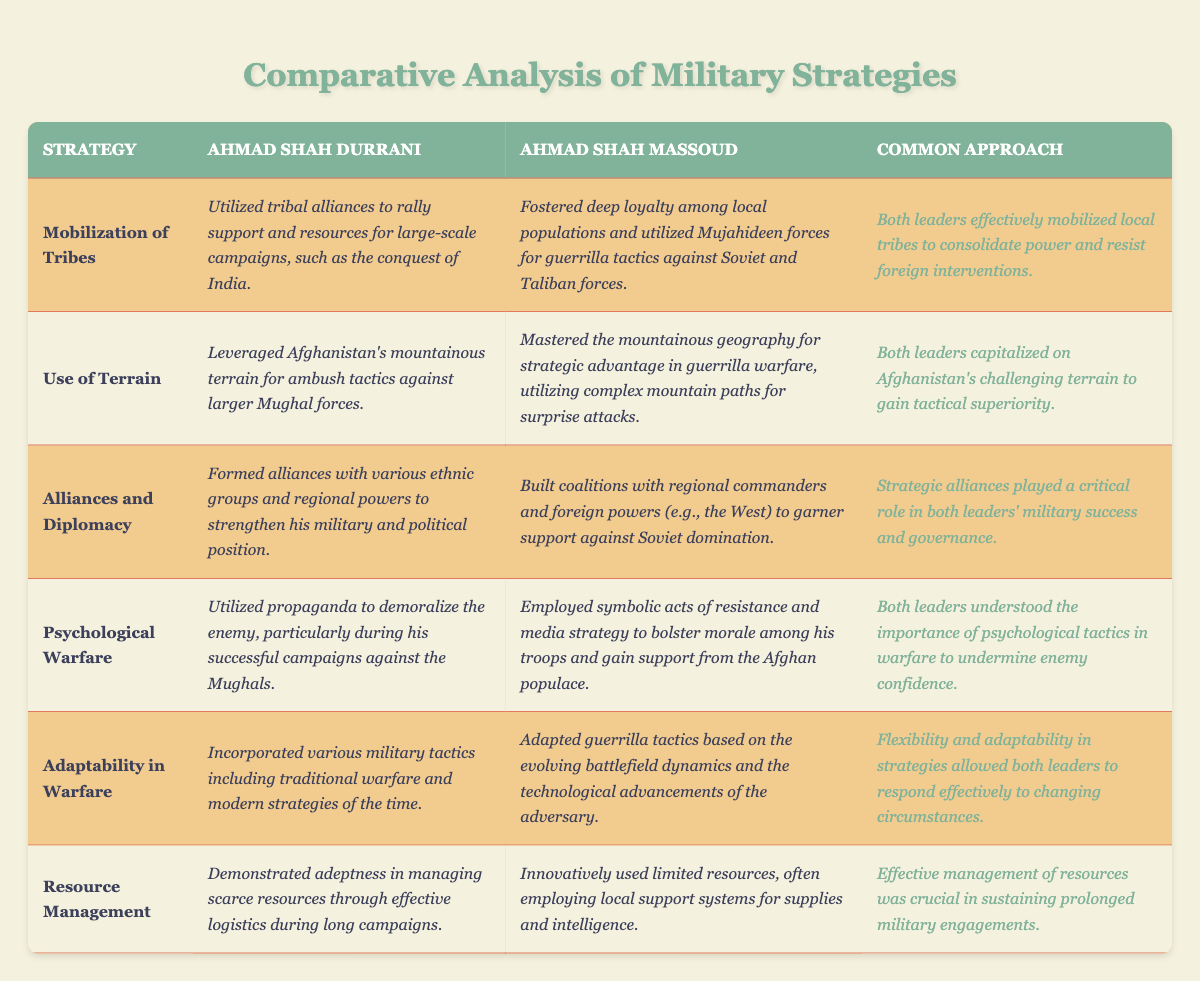What strategy did Ahmad Shah Durrani use to rally support for his campaigns? The table states that Ahmad Shah Durrani utilized tribal alliances for support and resources during his large-scale campaigns, particularly in the conquest of India.
Answer: Mobilization of Tribes How did both leaders approach the use of terrain in warfare? The table indicates that both Ahmad Shah Durrani and Ahmad Shah Massoud capitalized on Afghanistan's mountainous terrain, with Durrani leveraging it for ambushes and Massoud for guerrilla warfare tactics.
Answer: They capitalized on terrain Did Ahmad Shah Massoud form alliances to support his military efforts? According to the table, Ahmad Shah Massoud did build coalitions with regional commanders and foreign powers to gather support against the Soviets.
Answer: Yes What is the common approach both leaders took concerning resource management? The table shows that both leaders managed their resources effectively, with Durrani demonstrating adeptness during long campaigns and Massoud using local support systems for supplies.
Answer: Effective management of resources Which strategy employed by Ahmad Shah Massoud focused on morale and psychological tactics? The table states that Massoud employed symbolic acts of resistance and media strategy to boost troop morale and gain support, indicating a focus on psychological warfare.
Answer: Psychological Warfare How did the adaptability in warfare differ between Ahmad Shah Durrani and Ahmad Shah Massoud? While Ahmad Shah Durrani incorporated various military tactics of his time, Ahmad Shah Massoud adapted guerrilla tactics based on evolving battlefield dynamics and adversary advancements, showing a significant difference in their adaptability levels.
Answer: Durrani used varied tactics; Massoud adapted to dynamics What were the key similarities in the military strategies of Ahmad Shah Durrani and Ahmad Shah Massoud according to the table? The table lists several common approaches, including mobilization of tribes, effective resource management, and the use of terrain, which highlight their shared strategies.
Answer: Mobilization of tribes, resource management, use of terrain Did either Ahmad Shah Durrani or Ahmad Shah Massoud employ psychological warfare? Yes, the table indicates that both leaders understood and utilized psychological tactics to undermine enemy confidence in their respective campaigns.
Answer: Yes, both employed psychological warfare Which leader demonstrated better resource management according to the table? The table does not explicitly state that one leader was better than the other; rather, it highlights that both demonstrated effective resource management suited to their contexts.
Answer: Neither, both managed resources well How does the common approach regarding alliances and diplomacy contribute to military success for both leaders? The table notes that strategic alliances were critical for both leaders in enhancing their military and political positions, indicating that these alliances were integral to their military strategies.
Answer: Alliances were critical for success Which war strategies highlight the tactical superiority gained by both leaders? The table emphasizes their effective use of terrain, mobilization of tribes, and psychological warfare as key strategies that provided tactical superiority in their military endeavors.
Answer: Use of terrain, mobilization, psychological warfare 